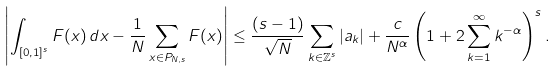Convert formula to latex. <formula><loc_0><loc_0><loc_500><loc_500>\left | \int _ { [ 0 , 1 ] ^ { s } } F ( x ) \, d x - \frac { 1 } { N } \sum _ { x \in P _ { N , s } } F ( x ) \right | \leq \frac { ( s - 1 ) } { \sqrt { N } } \sum _ { k \in \mathbb { Z } ^ { s } } | a _ { k } | + \frac { c } { N ^ { \alpha } } \left ( 1 + 2 \sum _ { k = 1 } ^ { \infty } k ^ { - \alpha } \right ) ^ { s } .</formula> 